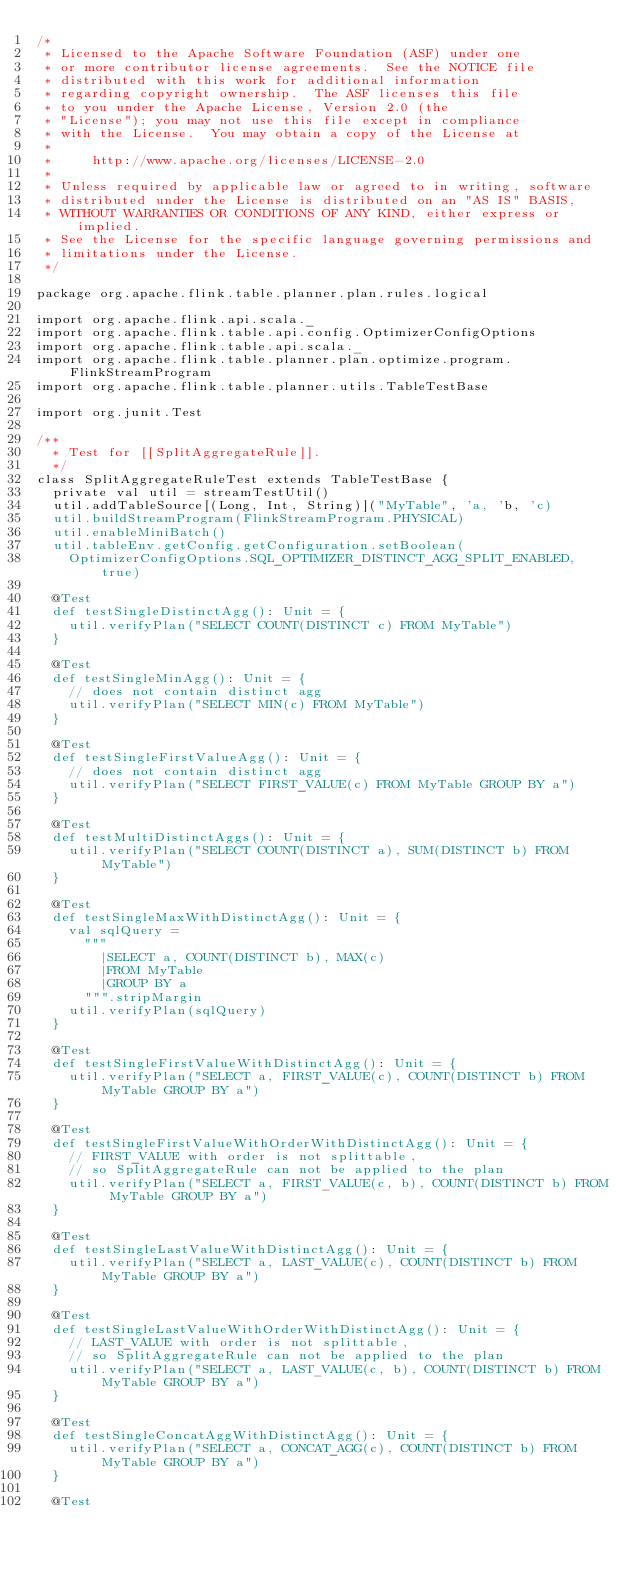<code> <loc_0><loc_0><loc_500><loc_500><_Scala_>/*
 * Licensed to the Apache Software Foundation (ASF) under one
 * or more contributor license agreements.  See the NOTICE file
 * distributed with this work for additional information
 * regarding copyright ownership.  The ASF licenses this file
 * to you under the Apache License, Version 2.0 (the
 * "License"); you may not use this file except in compliance
 * with the License.  You may obtain a copy of the License at
 *
 *     http://www.apache.org/licenses/LICENSE-2.0
 *
 * Unless required by applicable law or agreed to in writing, software
 * distributed under the License is distributed on an "AS IS" BASIS,
 * WITHOUT WARRANTIES OR CONDITIONS OF ANY KIND, either express or implied.
 * See the License for the specific language governing permissions and
 * limitations under the License.
 */

package org.apache.flink.table.planner.plan.rules.logical

import org.apache.flink.api.scala._
import org.apache.flink.table.api.config.OptimizerConfigOptions
import org.apache.flink.table.api.scala._
import org.apache.flink.table.planner.plan.optimize.program.FlinkStreamProgram
import org.apache.flink.table.planner.utils.TableTestBase

import org.junit.Test

/**
  * Test for [[SplitAggregateRule]].
  */
class SplitAggregateRuleTest extends TableTestBase {
  private val util = streamTestUtil()
  util.addTableSource[(Long, Int, String)]("MyTable", 'a, 'b, 'c)
  util.buildStreamProgram(FlinkStreamProgram.PHYSICAL)
  util.enableMiniBatch()
  util.tableEnv.getConfig.getConfiguration.setBoolean(
    OptimizerConfigOptions.SQL_OPTIMIZER_DISTINCT_AGG_SPLIT_ENABLED, true)

  @Test
  def testSingleDistinctAgg(): Unit = {
    util.verifyPlan("SELECT COUNT(DISTINCT c) FROM MyTable")
  }

  @Test
  def testSingleMinAgg(): Unit = {
    // does not contain distinct agg
    util.verifyPlan("SELECT MIN(c) FROM MyTable")
  }

  @Test
  def testSingleFirstValueAgg(): Unit = {
    // does not contain distinct agg
    util.verifyPlan("SELECT FIRST_VALUE(c) FROM MyTable GROUP BY a")
  }

  @Test
  def testMultiDistinctAggs(): Unit = {
    util.verifyPlan("SELECT COUNT(DISTINCT a), SUM(DISTINCT b) FROM MyTable")
  }

  @Test
  def testSingleMaxWithDistinctAgg(): Unit = {
    val sqlQuery =
      """
        |SELECT a, COUNT(DISTINCT b), MAX(c)
        |FROM MyTable
        |GROUP BY a
      """.stripMargin
    util.verifyPlan(sqlQuery)
  }

  @Test
  def testSingleFirstValueWithDistinctAgg(): Unit = {
    util.verifyPlan("SELECT a, FIRST_VALUE(c), COUNT(DISTINCT b) FROM MyTable GROUP BY a")
  }

  @Test
  def testSingleFirstValueWithOrderWithDistinctAgg(): Unit = {
    // FIRST_VALUE with order is not splittable,
    // so SplitAggregateRule can not be applied to the plan
    util.verifyPlan("SELECT a, FIRST_VALUE(c, b), COUNT(DISTINCT b) FROM MyTable GROUP BY a")
  }

  @Test
  def testSingleLastValueWithDistinctAgg(): Unit = {
    util.verifyPlan("SELECT a, LAST_VALUE(c), COUNT(DISTINCT b) FROM MyTable GROUP BY a")
  }

  @Test
  def testSingleLastValueWithOrderWithDistinctAgg(): Unit = {
    // LAST_VALUE with order is not splittable,
    // so SplitAggregateRule can not be applied to the plan
    util.verifyPlan("SELECT a, LAST_VALUE(c, b), COUNT(DISTINCT b) FROM MyTable GROUP BY a")
  }

  @Test
  def testSingleConcatAggWithDistinctAgg(): Unit = {
    util.verifyPlan("SELECT a, CONCAT_AGG(c), COUNT(DISTINCT b) FROM MyTable GROUP BY a")
  }

  @Test</code> 